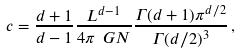Convert formula to latex. <formula><loc_0><loc_0><loc_500><loc_500>c = \frac { d + 1 } { d - 1 } \frac { L ^ { d - 1 } } { 4 \pi \ G N } \frac { \Gamma ( d + 1 ) \pi ^ { d / 2 } } { \Gamma ( d / 2 ) ^ { 3 } } \, ,</formula> 